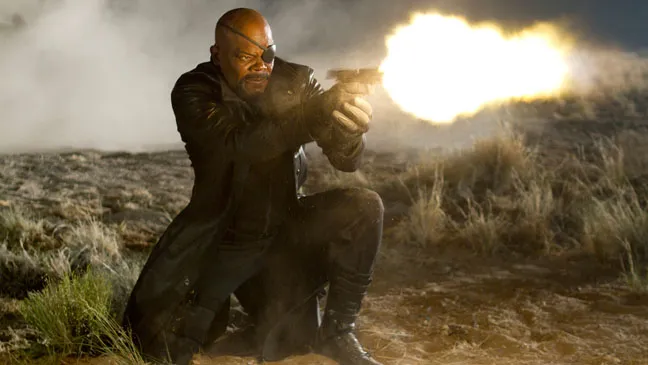Can you tell me more about the setting of this scene? The scene appears to be set in a rugged, desert-like environment, suggesting a remote and harsh location. The rocky terrain and sparse vegetation hint at a wilderness area far removed from any urban comforts. The dust and smoke hovering in the air create an atmosphere of recent turmoil, possibly from an ongoing battle or an earlier explosion. This setting contributes to the tense, high-stakes mood that surrounds the character, enhancing the sense of danger and urgency in the snapshot. Do you think this scene is part of a larger narrative? Yes, this scene likely plays a crucial part in a larger narrative. Given the character’s determined expression and the intense action captured, it's probable that this is a pivotal moment in a storyline involving conflict and high stakes. The character's iconic attire and the detailed setting suggest that this snapshot is part of a broader cinematic or graphic narrative arc that involves themes of heroism, resilience, and confrontation. 